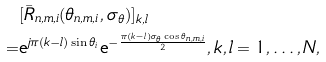<formula> <loc_0><loc_0><loc_500><loc_500>& [ \bar { R } _ { n , m , i } ( \theta _ { n , m , i } , \sigma _ { \theta } ) ] _ { k , l } \\ = & \text {e} ^ { j \pi ( k - l ) \sin \theta _ { i } } \text {e} ^ { - \frac { \pi ( k - l ) \sigma _ { \theta } \cos \theta _ { n , m , i } } { 2 } } , k , l = 1 , \dots , N ,</formula> 